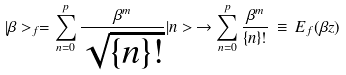<formula> <loc_0><loc_0><loc_500><loc_500>| \beta > _ { f } = \sum _ { n = 0 } ^ { p } \frac { \beta ^ { m } } { \sqrt { \{ n \} ! } } | n > \, \rightarrow \sum _ { n = 0 } ^ { p } \frac { \beta ^ { m } } { \{ n \} ! } \, \equiv \, E _ { f } ( \beta z )</formula> 